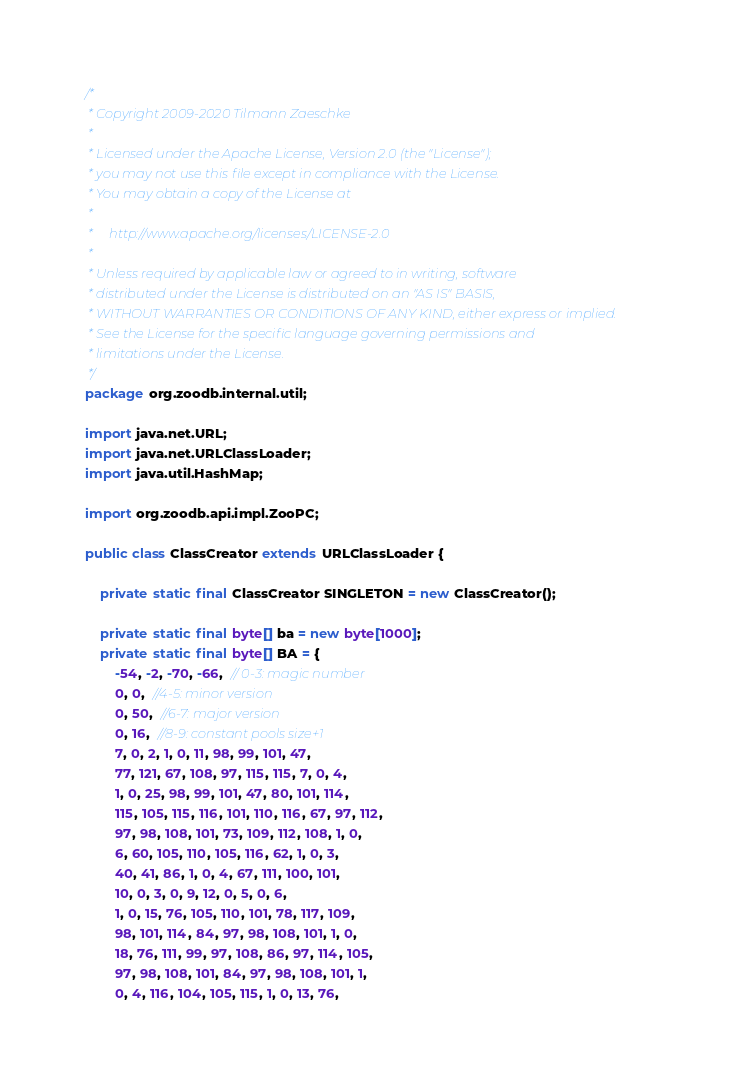<code> <loc_0><loc_0><loc_500><loc_500><_Java_>/*
 * Copyright 2009-2020 Tilmann Zaeschke
 *
 * Licensed under the Apache License, Version 2.0 (the "License");
 * you may not use this file except in compliance with the License.
 * You may obtain a copy of the License at
 *
 *     http://www.apache.org/licenses/LICENSE-2.0
 *
 * Unless required by applicable law or agreed to in writing, software
 * distributed under the License is distributed on an "AS IS" BASIS,
 * WITHOUT WARRANTIES OR CONDITIONS OF ANY KIND, either express or implied.
 * See the License for the specific language governing permissions and
 * limitations under the License.
 */
package org.zoodb.internal.util;

import java.net.URL;
import java.net.URLClassLoader;
import java.util.HashMap;

import org.zoodb.api.impl.ZooPC;

public class ClassCreator extends URLClassLoader {

	private static final ClassCreator SINGLETON = new ClassCreator(); 
	
	private static final byte[] ba = new byte[1000];
	private static final byte[] BA = {
		-54, -2, -70, -66,  // 0-3: magic number 
		0, 0,  //4-5: minor version 
		0, 50,  //6-7: major version 
		0, 16,  //8-9: constant pools size+1
		7, 0, 2, 1, 0, 11, 98, 99, 101, 47, 
		77, 121, 67, 108, 97, 115, 115, 7, 0, 4, 
		1, 0, 25, 98, 99, 101, 47, 80, 101, 114, 
		115, 105, 115, 116, 101, 110, 116, 67, 97, 112, 
		97, 98, 108, 101, 73, 109, 112, 108, 1, 0, 
		6, 60, 105, 110, 105, 116, 62, 1, 0, 3, 
		40, 41, 86, 1, 0, 4, 67, 111, 100, 101, 
		10, 0, 3, 0, 9, 12, 0, 5, 0, 6, 
		1, 0, 15, 76, 105, 110, 101, 78, 117, 109, 
		98, 101, 114, 84, 97, 98, 108, 101, 1, 0, 
		18, 76, 111, 99, 97, 108, 86, 97, 114, 105, 
		97, 98, 108, 101, 84, 97, 98, 108, 101, 1, 
		0, 4, 116, 104, 105, 115, 1, 0, 13, 76, </code> 